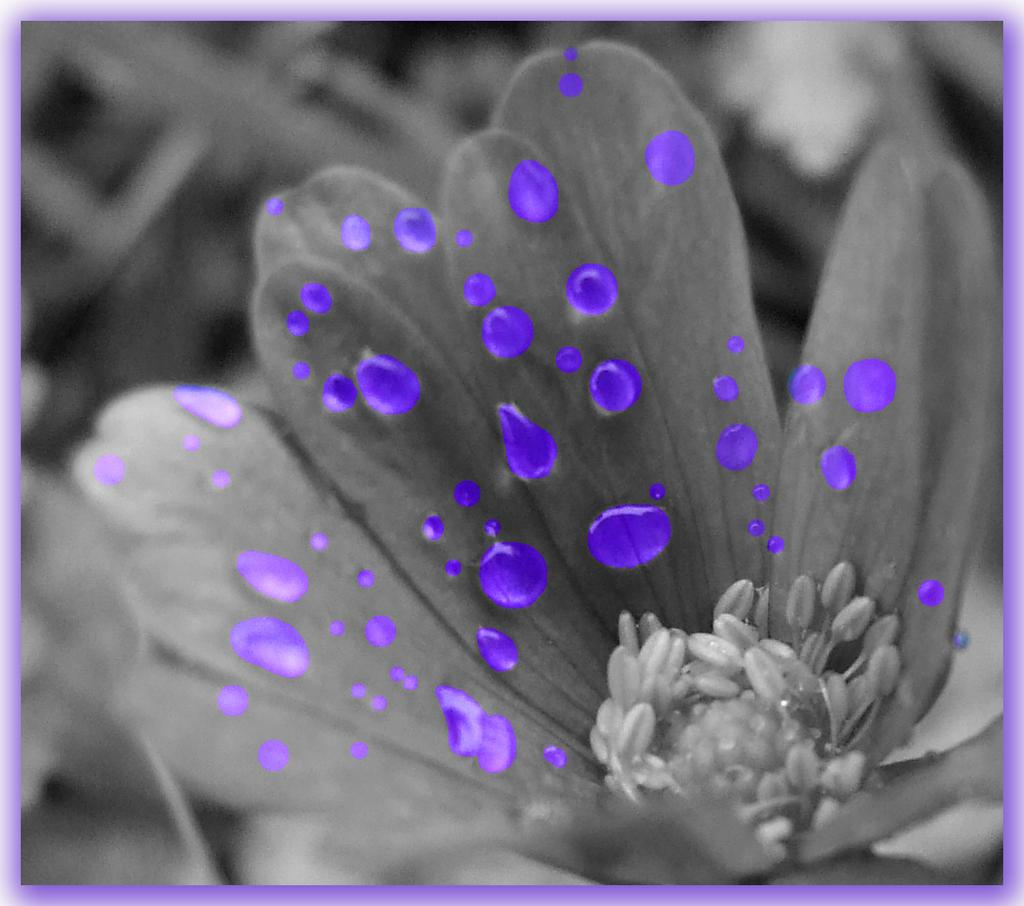What type of editing has been done to the image? The image is edited, but the specific type of editing is not mentioned in the facts. What is the color scheme of the flower in the image? The flower in the image is black and white. What additional elements are present on the flower? There are blue water drops on the flower. How does the ocean contribute to the destruction of the flower in the image? There is no ocean present in the image, and therefore no such destruction can be observed. 